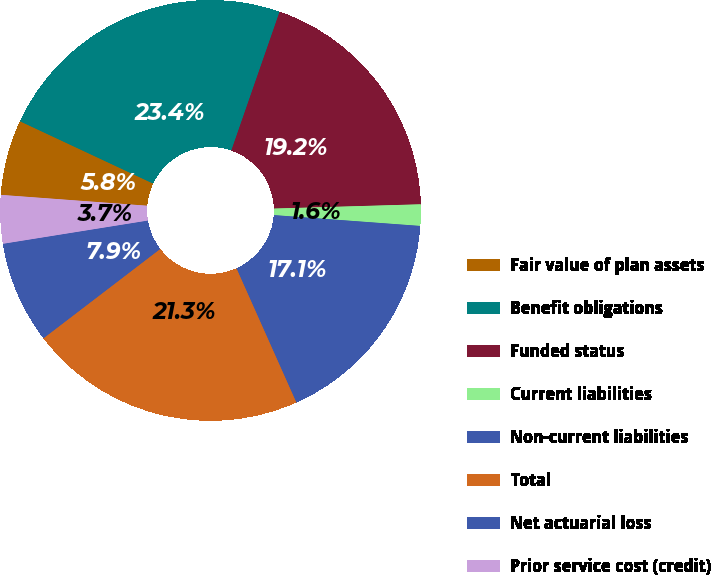Convert chart to OTSL. <chart><loc_0><loc_0><loc_500><loc_500><pie_chart><fcel>Fair value of plan assets<fcel>Benefit obligations<fcel>Funded status<fcel>Current liabilities<fcel>Non-current liabilities<fcel>Total<fcel>Net actuarial loss<fcel>Prior service cost (credit)<nl><fcel>5.79%<fcel>23.36%<fcel>19.21%<fcel>1.64%<fcel>17.14%<fcel>21.29%<fcel>7.86%<fcel>3.71%<nl></chart> 